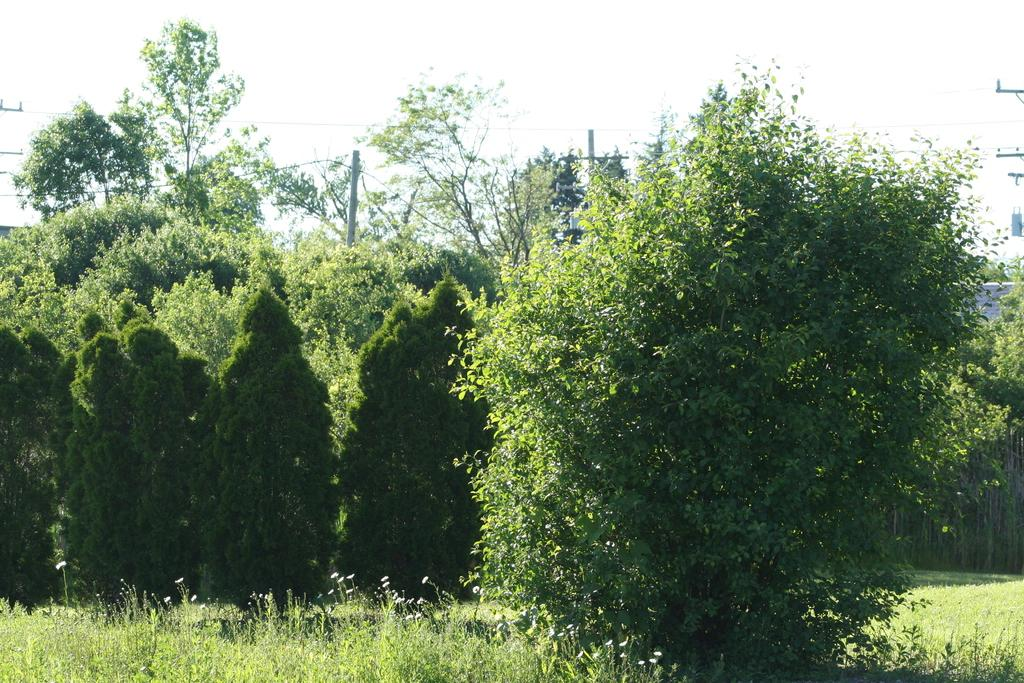What type of vegetation can be seen towards the right side of the image? There is a plant towards the right side of the image. What other plants are visible in the image? There are plants at the bottom of the image. What can be seen in the background of the image? There are trees and poles in the background of the image. Can you see any dogs playing in the sea in the image? There is no sea or dogs present in the image. What type of lunch is being served in the image? There is no lunch or any food being served in the image. 